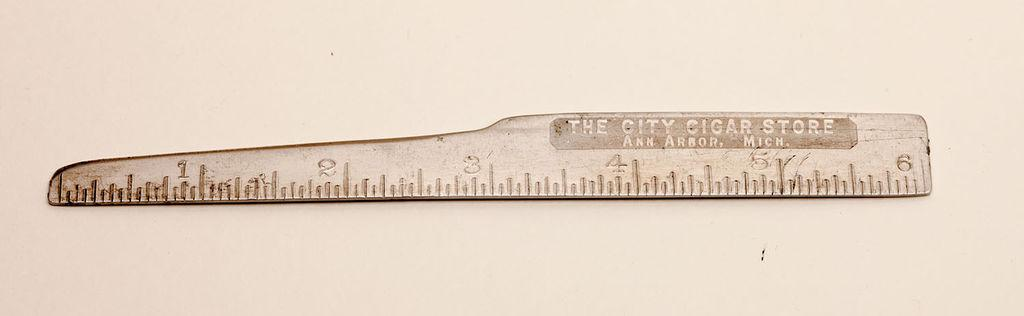<image>
Share a concise interpretation of the image provided. A silver device which has the words The City Cigar Store written on it. 